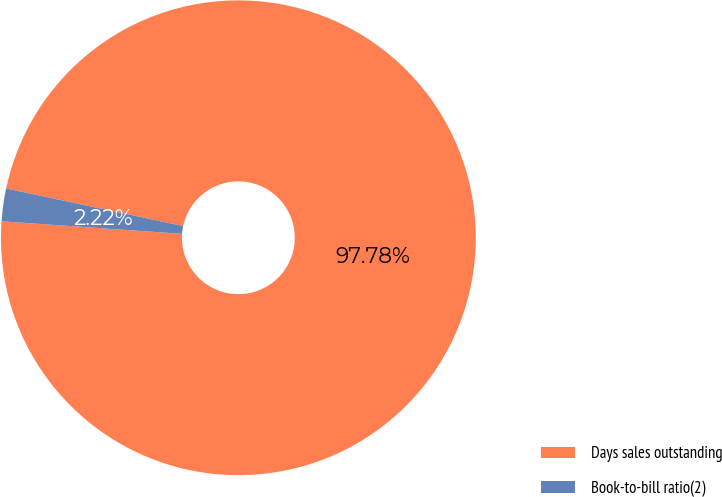<chart> <loc_0><loc_0><loc_500><loc_500><pie_chart><fcel>Days sales outstanding<fcel>Book-to-bill ratio(2)<nl><fcel>97.78%<fcel>2.22%<nl></chart> 